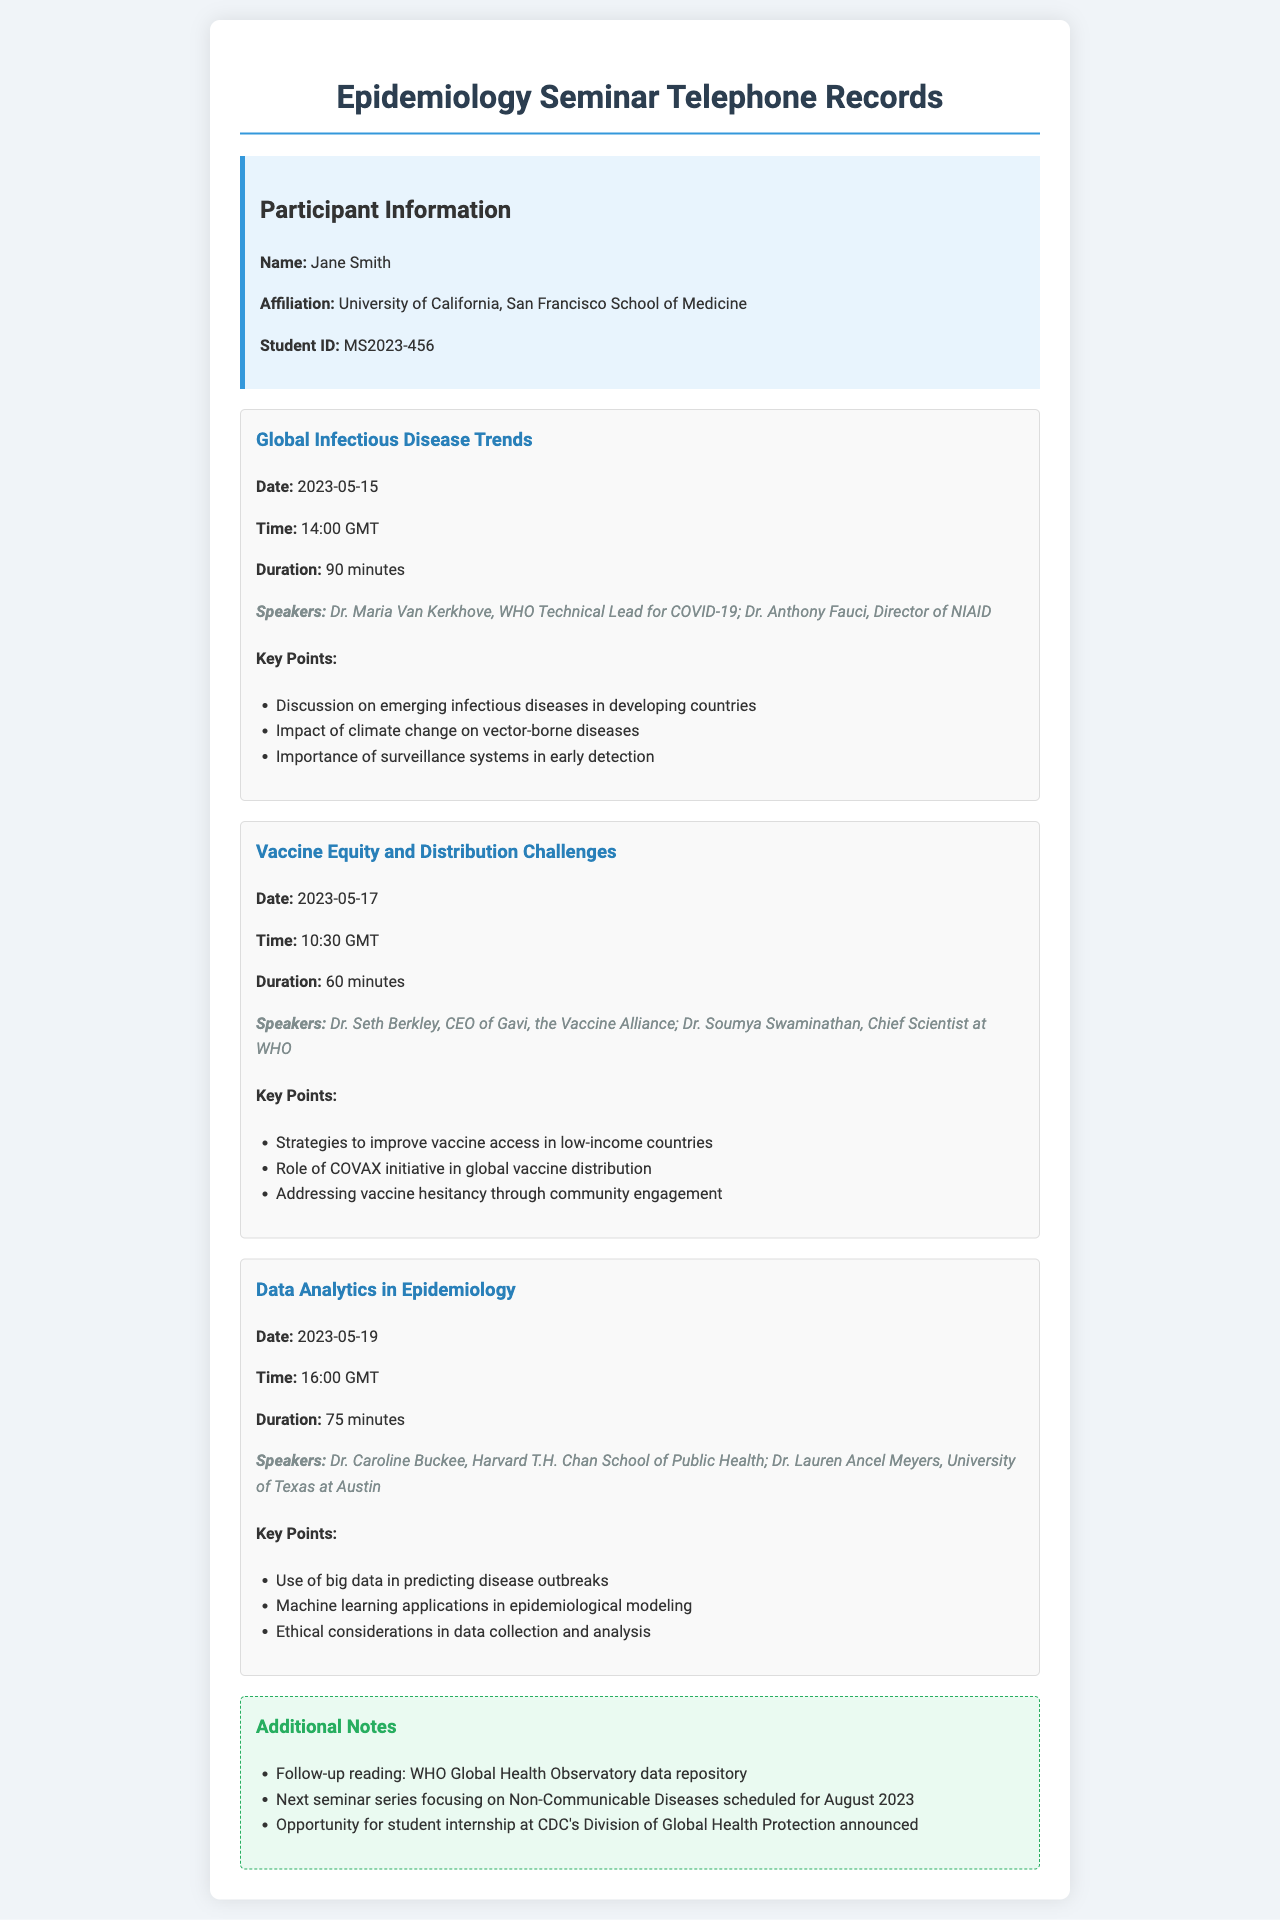What was the date of the "Global Infectious Disease Trends" call? The date of the call is explicitly stated in the document under the call record section.
Answer: 2023-05-15 Who were the speakers for the "Vaccine Equity and Distribution Challenges" call? The speakers for this call are listed within the call record with their titles.
Answer: Dr. Seth Berkley, Dr. Soumya Swaminathan What was the duration of the "Data Analytics in Epidemiology" call? The duration for this call can be found in the call record details under the duration section.
Answer: 75 minutes Which organization is Dr. Maria Van Kerkhove affiliated with? The document mentions her affiliation under the speakers section for the relevant call.
Answer: WHO What key point was discussed in the "Global Infectious Disease Trends" call? Key points are specified under each call record, providing insights into the discussion topics.
Answer: Importance of surveillance systems in early detection What is the next seminar series scheduled after these calls? The next seminar information is noted in the additional notes section at the end of the document.
Answer: Non-Communicable Diseases What ethical considerations were mentioned in the "Data Analytics in Epidemiology" call? Ethical considerations are listed as one of the key points discussed in this call record.
Answer: Ethical considerations in data collection and analysis How many calls were summarized in the document? By counting the distinct call records presented in the document, the total can be determined.
Answer: Three calls 